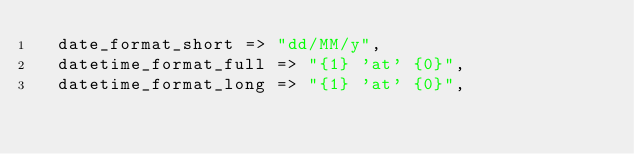<code> <loc_0><loc_0><loc_500><loc_500><_Perl_>  date_format_short => "dd/MM/y",
  datetime_format_full => "{1} 'at' {0}",
  datetime_format_long => "{1} 'at' {0}",</code> 